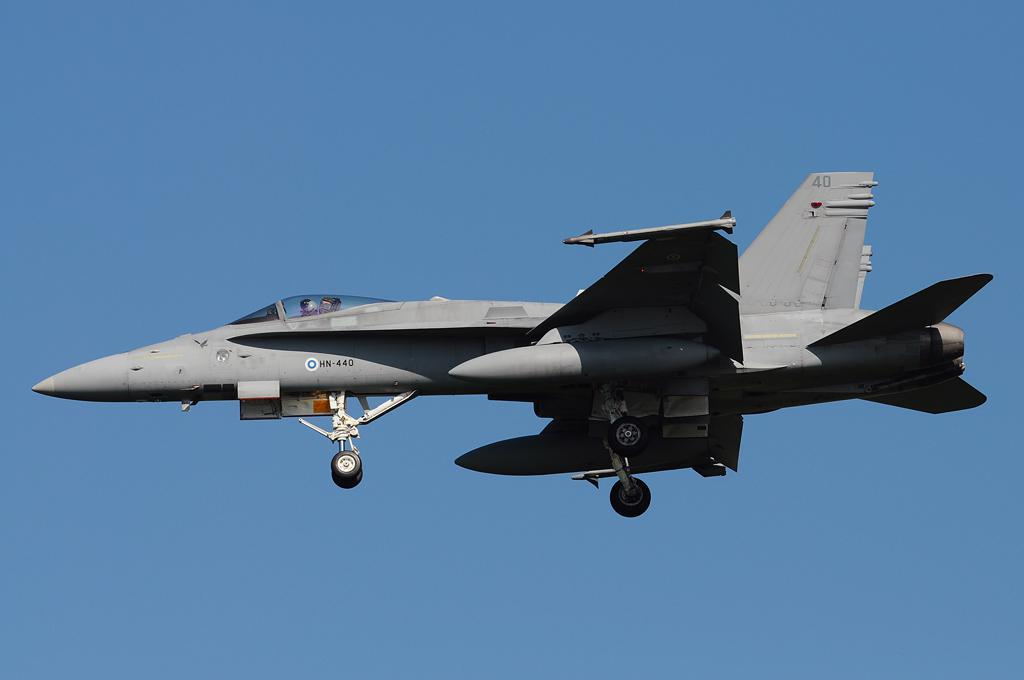What is the main subject of the image? The main subject of the image is an aircraft. What is the aircraft doing in the image? The aircraft is flying in the sky. How many people are visible inside the aircraft? There are two persons sitting in the aircraft. What can be seen in the background of the image? The sky is visible in the background of the image. Can you describe the condition of the sky in the image? The sky appears to be clear in the image. What type of silk fabric is draped over the frame of the aircraft in the image? There is no silk fabric or frame present in the image; it features an aircraft flying in the sky with two people inside. How many frogs can be seen hopping around the aircraft in the image? There are no frogs present in the image; it only features an aircraft flying in the sky. 